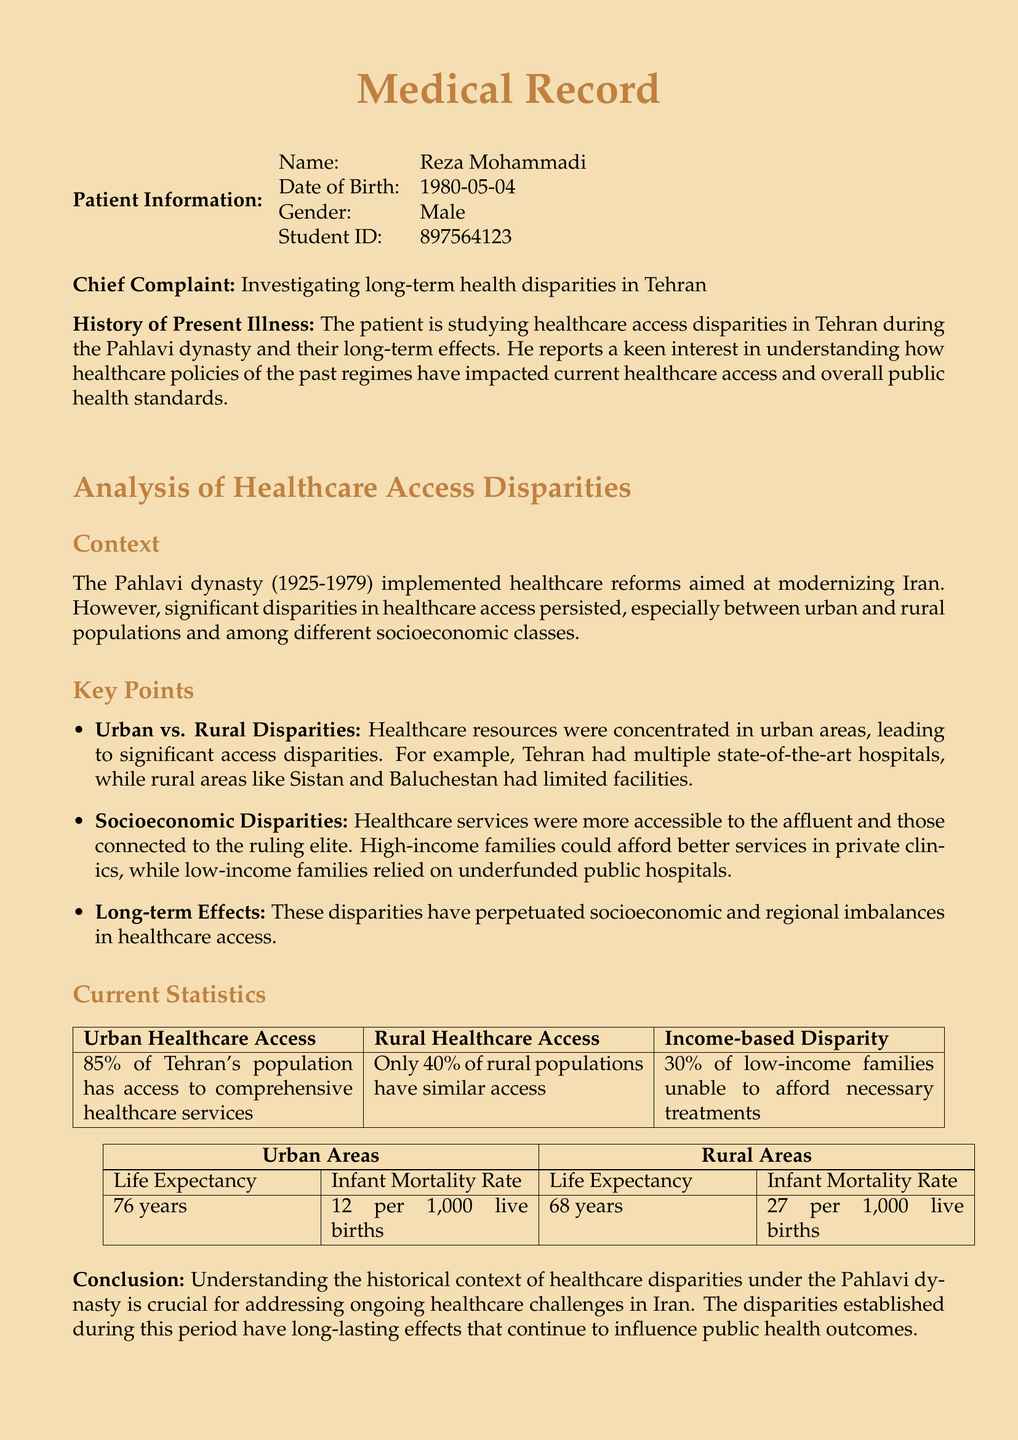What is the patient's name? The patient's name is listed in the patient information section of the document.
Answer: Reza Mohammadi What percentage of Tehran's population has access to comprehensive healthcare services? The percentage is specified in the current statistics section of the document.
Answer: 85% What is the infant mortality rate in urban areas? The rate is given in the table comparing urban and rural areas under the key points.
Answer: 12 per 1,000 live births What is noted as a key demographic divide in healthcare access? The document outlines disparities focusing on urban versus rural populations and socioeconomic status.
Answer: Urban vs. Rural Disparities What is the life expectancy in rural areas? The life expectancy is provided in the urban and rural area statistics table.
Answer: 68 years What does the document conclude about the importance of historical context? The conclusion states that understanding this context is crucial for future healthcare challenges.
Answer: Crucial for addressing ongoing healthcare challenges 